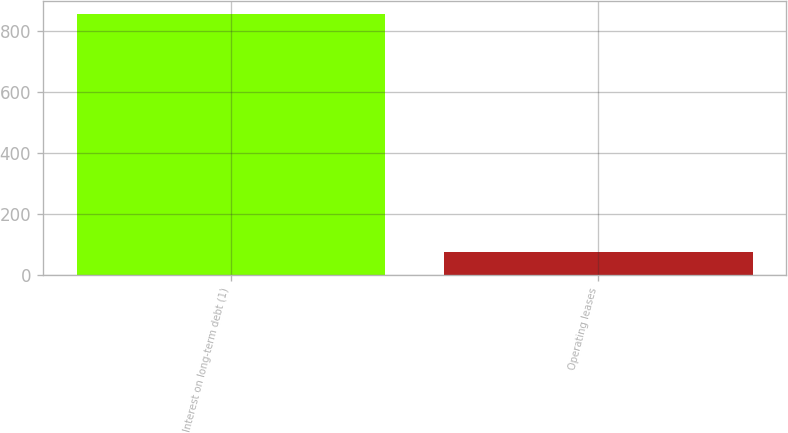<chart> <loc_0><loc_0><loc_500><loc_500><bar_chart><fcel>Interest on long-term debt (1)<fcel>Operating leases<nl><fcel>855<fcel>75<nl></chart> 